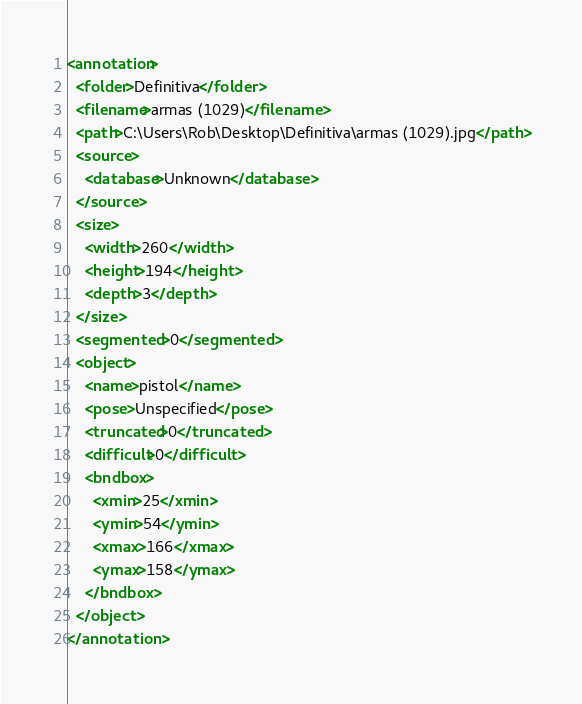Convert code to text. <code><loc_0><loc_0><loc_500><loc_500><_XML_><annotation>
  <folder>Definitiva</folder>
  <filename>armas (1029)</filename>
  <path>C:\Users\Rob\Desktop\Definitiva\armas (1029).jpg</path>
  <source>
    <database>Unknown</database>
  </source>
  <size>
    <width>260</width>
    <height>194</height>
    <depth>3</depth>
  </size>
  <segmented>0</segmented>
  <object>
    <name>pistol</name>
    <pose>Unspecified</pose>
    <truncated>0</truncated>
    <difficult>0</difficult>
    <bndbox>
      <xmin>25</xmin>
      <ymin>54</ymin>
      <xmax>166</xmax>
      <ymax>158</ymax>
    </bndbox>
  </object>
</annotation>
</code> 